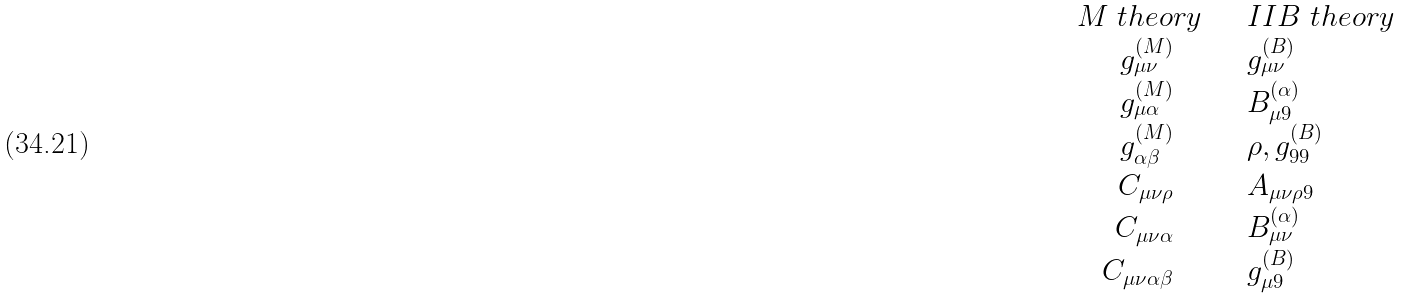<formula> <loc_0><loc_0><loc_500><loc_500>\begin{array} { r l } { M \ t h e o r y } & { \quad I I B \ t h e o r y } \\ { { g _ { \mu \nu } ^ { ( M ) } \quad } } & { { \quad g _ { \mu \nu } ^ { ( B ) } } } \\ { { g _ { \mu \alpha } ^ { ( M ) } \quad } } & { { \quad B _ { \mu 9 } ^ { ( \alpha ) } } } \\ { { g _ { \alpha \beta } ^ { ( M ) } \quad } } & { { \quad \rho , g _ { 9 9 } ^ { ( B ) } } } \\ { { C _ { \mu \nu \rho } \quad } } & { { \quad A _ { \mu \nu \rho 9 } } } \\ { { C _ { \mu \nu \alpha } \quad } } & { { \quad B _ { \mu \nu } ^ { ( \alpha ) } } } \\ { { C _ { \mu \nu \alpha \beta } \quad } } & { { \quad g _ { \mu 9 } ^ { ( B ) } } } \end{array}</formula> 